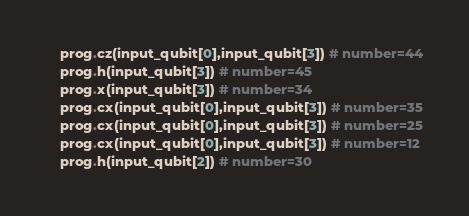Convert code to text. <code><loc_0><loc_0><loc_500><loc_500><_Python_>    prog.cz(input_qubit[0],input_qubit[3]) # number=44
    prog.h(input_qubit[3]) # number=45
    prog.x(input_qubit[3]) # number=34
    prog.cx(input_qubit[0],input_qubit[3]) # number=35
    prog.cx(input_qubit[0],input_qubit[3]) # number=25
    prog.cx(input_qubit[0],input_qubit[3]) # number=12
    prog.h(input_qubit[2]) # number=30</code> 